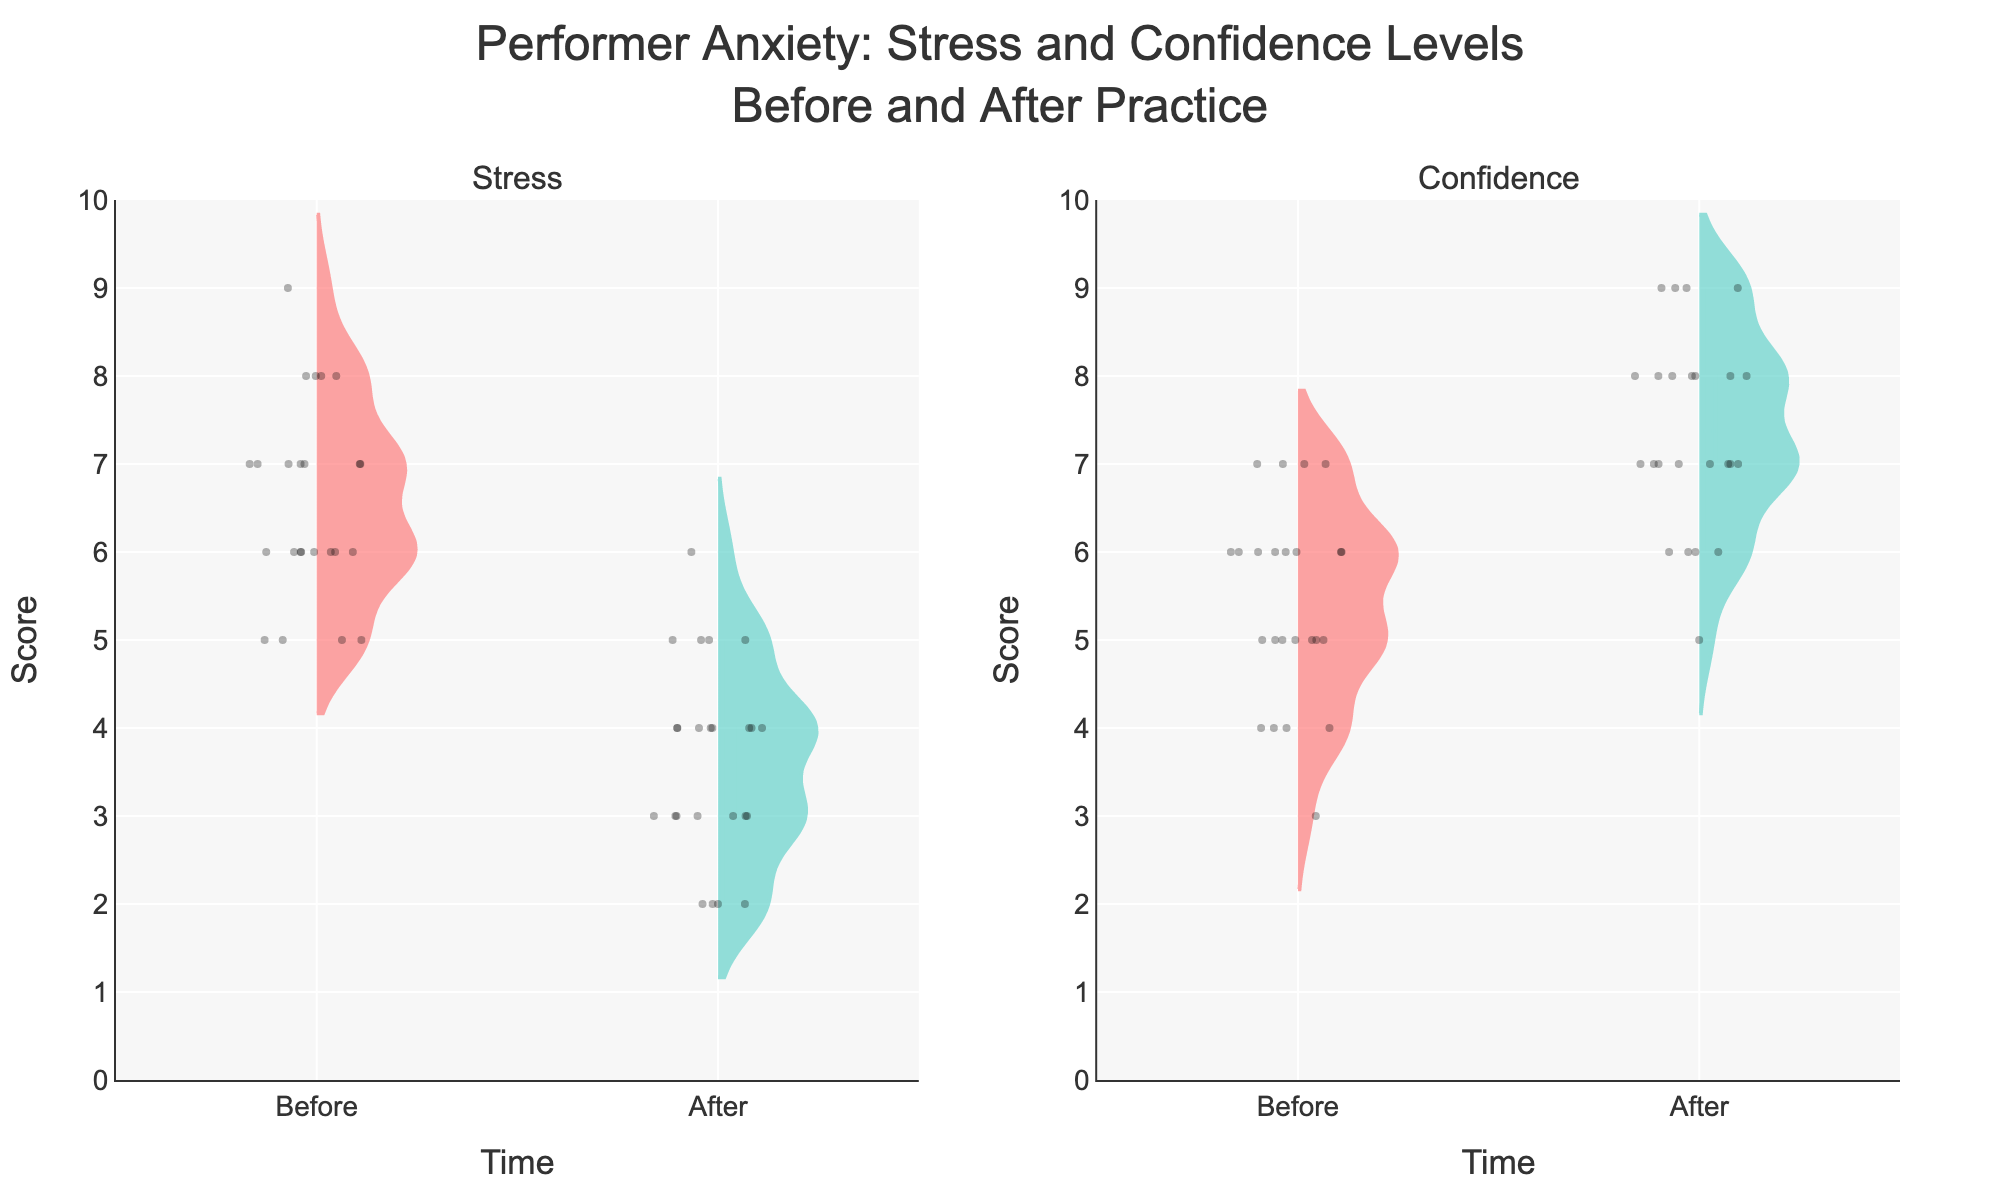What is the title of the figure? The title is located at the top center of the figure. It reads: "Performer Anxiety: Stress and Confidence Levels Before and After Practice".
Answer: Performer Anxiety: Stress and Confidence Levels Before and After Practice What colors are used to represent the 'Before' and 'After' conditions in the plot? The violin plots and points use different colors to represent 'Before' and 'After' conditions. 'Before' is represented by a reddish color, and 'After' is represented by a teal color.
Answer: 'Before' is reddish; 'After' is teal Which measure has lower average scores, Stress or Confidence? By observing the violin plots and their mean lines, the mean line for Stress is generally higher on the y-axis compared to Confidence across both 'Before' and 'After' conditions. This implies that Confidence has lower average scores than Stress.
Answer: Confidence What is the range of the y-axis? The y-axis range is given by the visible scale on the left. It starts at 0 and goes up to 10.
Answer: 0 to 10 How does the median value of Stress Before compare to Confidence After? The median value for Stress Before is visible inside the box within the violin plot on the left side; similarly, the median for Confidence After is visible within the box on the right. By comparing, the median for Stress Before is higher than that for Confidence After.
Answer: Median for Stress Before is higher How many columns of subplots are there in the figure? The plot is divided into two columns, as indicated by the two subplot titles 'Stress' and 'Confidence' at the top.
Answer: 2 What is the score difference between the median stress before and after practice? The median lines on the violin plots (before and after) for stress provide these values. The score difference is the value on the y-axis where the 'Before' and 'After' median lines are. Compute the difference between these y-values.
Answer: Difference is approximately 2 Which condition shows more variation in scores: Stress Before practice or Confidence After practice? The width of the violin plots and the spread of jittered points are a visual indicator of variability. The plot for Stress Before practice seems wider and thus indicates more variation compared to Confidence After practice.
Answer: Stress Before practice Did Stress levels generally increase or decrease after practice? By comparing the 'Before' and 'After' sections of the Stress figures, it is apparent that the levels generally decrease after practice as the 'After' median and spread are lower on the y-axis.
Answer: Decrease 